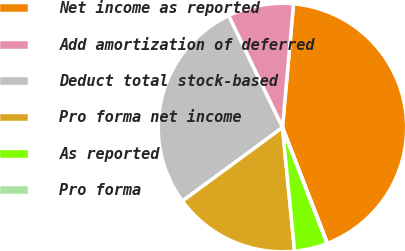Convert chart to OTSL. <chart><loc_0><loc_0><loc_500><loc_500><pie_chart><fcel>Net income as reported<fcel>Add amortization of deferred<fcel>Deduct total stock-based<fcel>Pro forma net income<fcel>As reported<fcel>Pro forma<nl><fcel>42.69%<fcel>8.56%<fcel>27.95%<fcel>16.47%<fcel>4.3%<fcel>0.03%<nl></chart> 